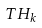<formula> <loc_0><loc_0><loc_500><loc_500>T H _ { k }</formula> 